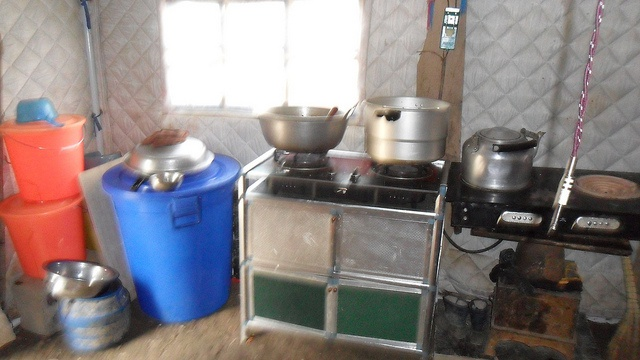Describe the objects in this image and their specific colors. I can see oven in darkgray, gray, black, and darkgreen tones, bowl in darkgray and gray tones, bowl in darkgray, lightgray, and gray tones, bowl in darkgray, gray, lightgray, and maroon tones, and bowl in darkgray, lightgray, and gray tones in this image. 